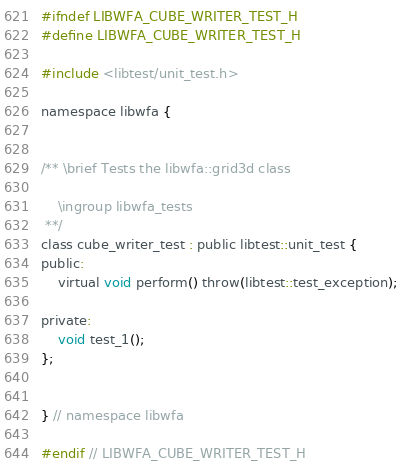<code> <loc_0><loc_0><loc_500><loc_500><_C_>#ifndef LIBWFA_CUBE_WRITER_TEST_H
#define LIBWFA_CUBE_WRITER_TEST_H

#include <libtest/unit_test.h>

namespace libwfa {


/** \brief Tests the libwfa::grid3d class

    \ingroup libwfa_tests
 **/
class cube_writer_test : public libtest::unit_test {
public:
    virtual void perform() throw(libtest::test_exception);

private:
    void test_1();
};


} // namespace libwfa

#endif // LIBWFA_CUBE_WRITER_TEST_H
</code> 